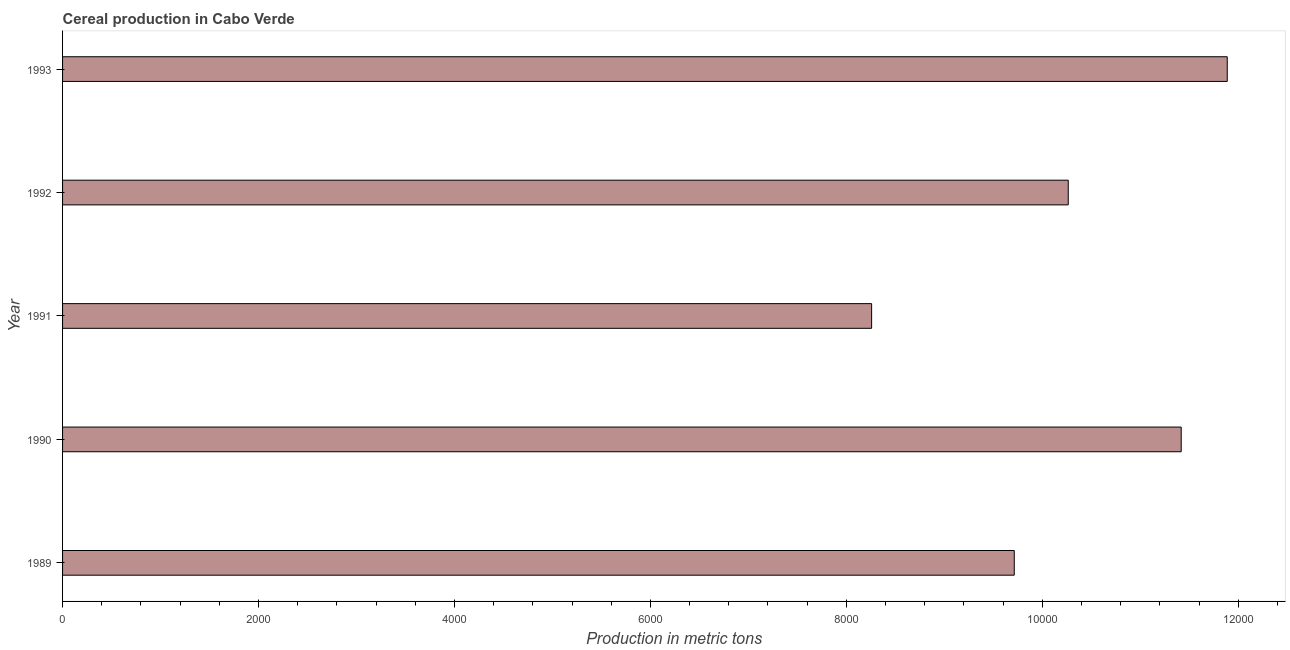Does the graph contain any zero values?
Your answer should be compact. No. What is the title of the graph?
Make the answer very short. Cereal production in Cabo Verde. What is the label or title of the X-axis?
Offer a terse response. Production in metric tons. What is the label or title of the Y-axis?
Provide a short and direct response. Year. What is the cereal production in 1991?
Your answer should be very brief. 8258. Across all years, what is the maximum cereal production?
Make the answer very short. 1.19e+04. Across all years, what is the minimum cereal production?
Offer a terse response. 8258. In which year was the cereal production minimum?
Give a very brief answer. 1991. What is the sum of the cereal production?
Your response must be concise. 5.15e+04. What is the difference between the cereal production in 1989 and 1991?
Keep it short and to the point. 1456. What is the average cereal production per year?
Your answer should be compact. 1.03e+04. What is the median cereal production?
Offer a very short reply. 1.03e+04. Do a majority of the years between 1993 and 1989 (inclusive) have cereal production greater than 10000 metric tons?
Give a very brief answer. Yes. What is the ratio of the cereal production in 1992 to that in 1993?
Your answer should be very brief. 0.86. Is the cereal production in 1989 less than that in 1990?
Ensure brevity in your answer.  Yes. Is the difference between the cereal production in 1990 and 1992 greater than the difference between any two years?
Give a very brief answer. No. What is the difference between the highest and the second highest cereal production?
Ensure brevity in your answer.  470. Is the sum of the cereal production in 1991 and 1993 greater than the maximum cereal production across all years?
Ensure brevity in your answer.  Yes. What is the difference between the highest and the lowest cereal production?
Your answer should be very brief. 3630. In how many years, is the cereal production greater than the average cereal production taken over all years?
Give a very brief answer. 2. How many bars are there?
Provide a short and direct response. 5. How many years are there in the graph?
Provide a short and direct response. 5. What is the difference between two consecutive major ticks on the X-axis?
Keep it short and to the point. 2000. Are the values on the major ticks of X-axis written in scientific E-notation?
Make the answer very short. No. What is the Production in metric tons of 1989?
Ensure brevity in your answer.  9714. What is the Production in metric tons of 1990?
Keep it short and to the point. 1.14e+04. What is the Production in metric tons in 1991?
Offer a very short reply. 8258. What is the Production in metric tons of 1992?
Make the answer very short. 1.03e+04. What is the Production in metric tons in 1993?
Your answer should be very brief. 1.19e+04. What is the difference between the Production in metric tons in 1989 and 1990?
Your answer should be compact. -1704. What is the difference between the Production in metric tons in 1989 and 1991?
Offer a very short reply. 1456. What is the difference between the Production in metric tons in 1989 and 1992?
Your answer should be compact. -551. What is the difference between the Production in metric tons in 1989 and 1993?
Give a very brief answer. -2174. What is the difference between the Production in metric tons in 1990 and 1991?
Ensure brevity in your answer.  3160. What is the difference between the Production in metric tons in 1990 and 1992?
Keep it short and to the point. 1153. What is the difference between the Production in metric tons in 1990 and 1993?
Give a very brief answer. -470. What is the difference between the Production in metric tons in 1991 and 1992?
Offer a terse response. -2007. What is the difference between the Production in metric tons in 1991 and 1993?
Make the answer very short. -3630. What is the difference between the Production in metric tons in 1992 and 1993?
Keep it short and to the point. -1623. What is the ratio of the Production in metric tons in 1989 to that in 1990?
Your answer should be compact. 0.85. What is the ratio of the Production in metric tons in 1989 to that in 1991?
Ensure brevity in your answer.  1.18. What is the ratio of the Production in metric tons in 1989 to that in 1992?
Offer a terse response. 0.95. What is the ratio of the Production in metric tons in 1989 to that in 1993?
Ensure brevity in your answer.  0.82. What is the ratio of the Production in metric tons in 1990 to that in 1991?
Provide a succinct answer. 1.38. What is the ratio of the Production in metric tons in 1990 to that in 1992?
Give a very brief answer. 1.11. What is the ratio of the Production in metric tons in 1991 to that in 1992?
Offer a terse response. 0.8. What is the ratio of the Production in metric tons in 1991 to that in 1993?
Your answer should be very brief. 0.69. What is the ratio of the Production in metric tons in 1992 to that in 1993?
Provide a succinct answer. 0.86. 